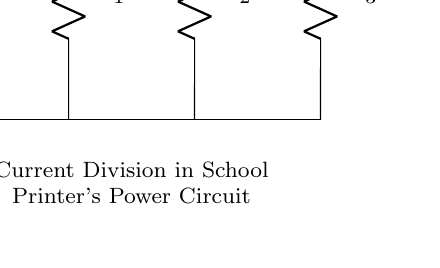What does the symbol "V_s" represent in this circuit? The symbol "V_s" represents the source voltage, which is the voltage supplied to the circuit from an external source.
Answer: Source voltage What are the resistance values in this power distribution circuit? The circuit includes three resistors labeled R_1, R_2, and R_3, but specific resistance values are not mentioned in the diagram.
Answer: R_1, R_2, R_3 What is the total current entering the circuit? The total current entering the circuit is represented by "I_T", indicating the sum of the currents flowing through all branches.
Answer: I_T How is the current divided among the resistors? The current divides based on the resistance values of the individual resistors (R_1, R_2, and R_3), following Ohm's Law. It flows proportionally, so resistor values affect how much current each one gets.
Answer: Proportionally If R_1 is 10 Ohms, R_2 is 20 Ohms, and R_3 is 30 Ohms, what is the relationship between the currents I_1, I_2, and I_3? The currents I_1, I_2, and I_3 will be inversely proportional to their respective resistances because they share the same total voltage across them. This means I_1 is the largest and I_3 is the smallest as R_3 has the highest resistance.
Answer: Inversely proportional Which branch has the lowest current? The branch with the highest resistance (R_3) will have the lowest current according to the current division rule.
Answer: R_3 What type of circuit configuration is depicted in this diagram? The configuration is a parallel circuit, where multiple branches allow the current to divide among the resistors.
Answer: Parallel circuit 